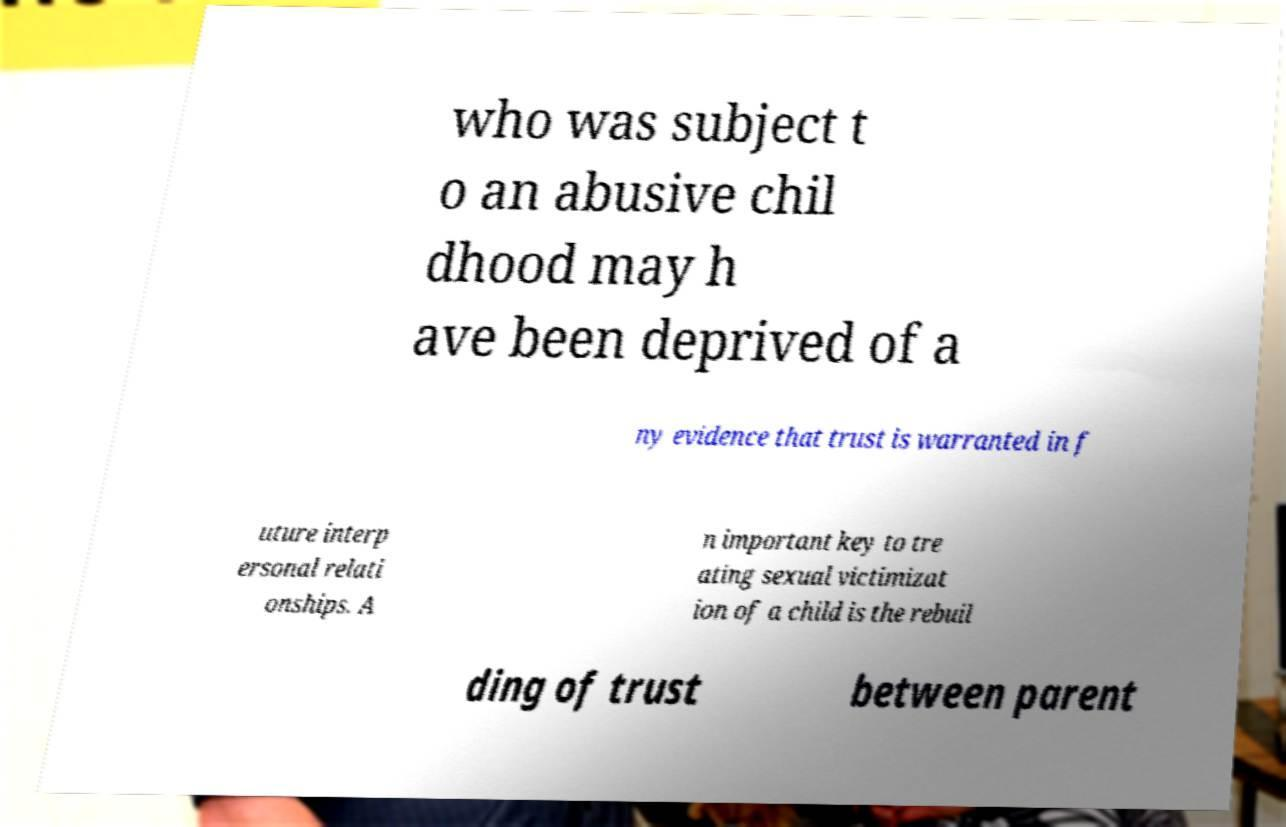Could you extract and type out the text from this image? who was subject t o an abusive chil dhood may h ave been deprived of a ny evidence that trust is warranted in f uture interp ersonal relati onships. A n important key to tre ating sexual victimizat ion of a child is the rebuil ding of trust between parent 